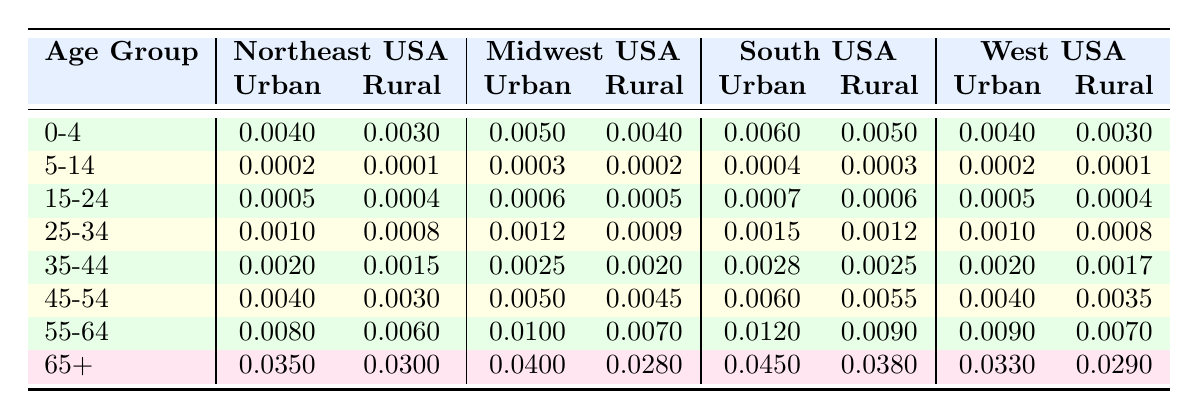What is the mortality rate for the age group 55-64 in urban populations in the Northeast USA? In the table, I look under the Northeast USA region and find the row for the age group 55-64. The urban mortality rate listed there is 0.0080.
Answer: 0.0080 What is the mortality rate for the age group 0-4 in rural populations in the South USA? In the table, I check the South USA section and locate the row for age group 0-4. The rural mortality rate for that age group is 0.0050.
Answer: 0.0050 True or False: The urban mortality rate for the age group 25-34 is higher in the Midwest USA than in the Northeast USA. I compare the urban mortality rate for the age group 25-34 in both regions. Northeast USA has 0.0010 and Midwest USA has 0.0012. Since 0.0012 is higher than 0.0010, the statement is true.
Answer: True What is the difference between the rural mortality rates for the age group 65+ in the Midwest USA and the West USA? Checking the table, the rural mortality rate for age group 65+ in Midwest USA is 0.0280, and for West USA, it is 0.0290. The difference is 0.0290 - 0.0280 = 0.0010.
Answer: 0.0010 Which age group shows the largest urban mortality rate in the South USA? I review the urban mortality rates for all age groups in South USA from the table. The age group 65+ has the highest rate at 0.0450, which is higher than all other age groups.
Answer: 65+ What is the average urban mortality rate of the age group 5-14 across all regions? I first find the urban mortality rates for the age group 5-14: 0.0002 (Northeast), 0.0003 (Midwest), 0.0004 (South), and 0.0002 (West). Summing these gives 0.0002 + 0.0003 + 0.0004 + 0.0002 = 0.0011. There are 4 data points so I divide by 4, yielding an average of 0.000275.
Answer: 0.000275 True or False: The rural mortality rate for the age group 45-54 in the Northeast USA is lower than that in the South USA. The rural mortality rates for 45-54 are 0.0030 (Northeast) and 0.0055 (South). Since 0.0030 is less than 0.0055, the statement is true.
Answer: True What is the highest urban mortality rate for the age group 15-24 in any region? I look at the table and find the urban mortality rates for age group 15-24: 0.0005 (Northeast), 0.0006 (Midwest), 0.0007 (South), and 0.0005 (West). The highest one is 0.0007 from the South USA.
Answer: 0.0007 